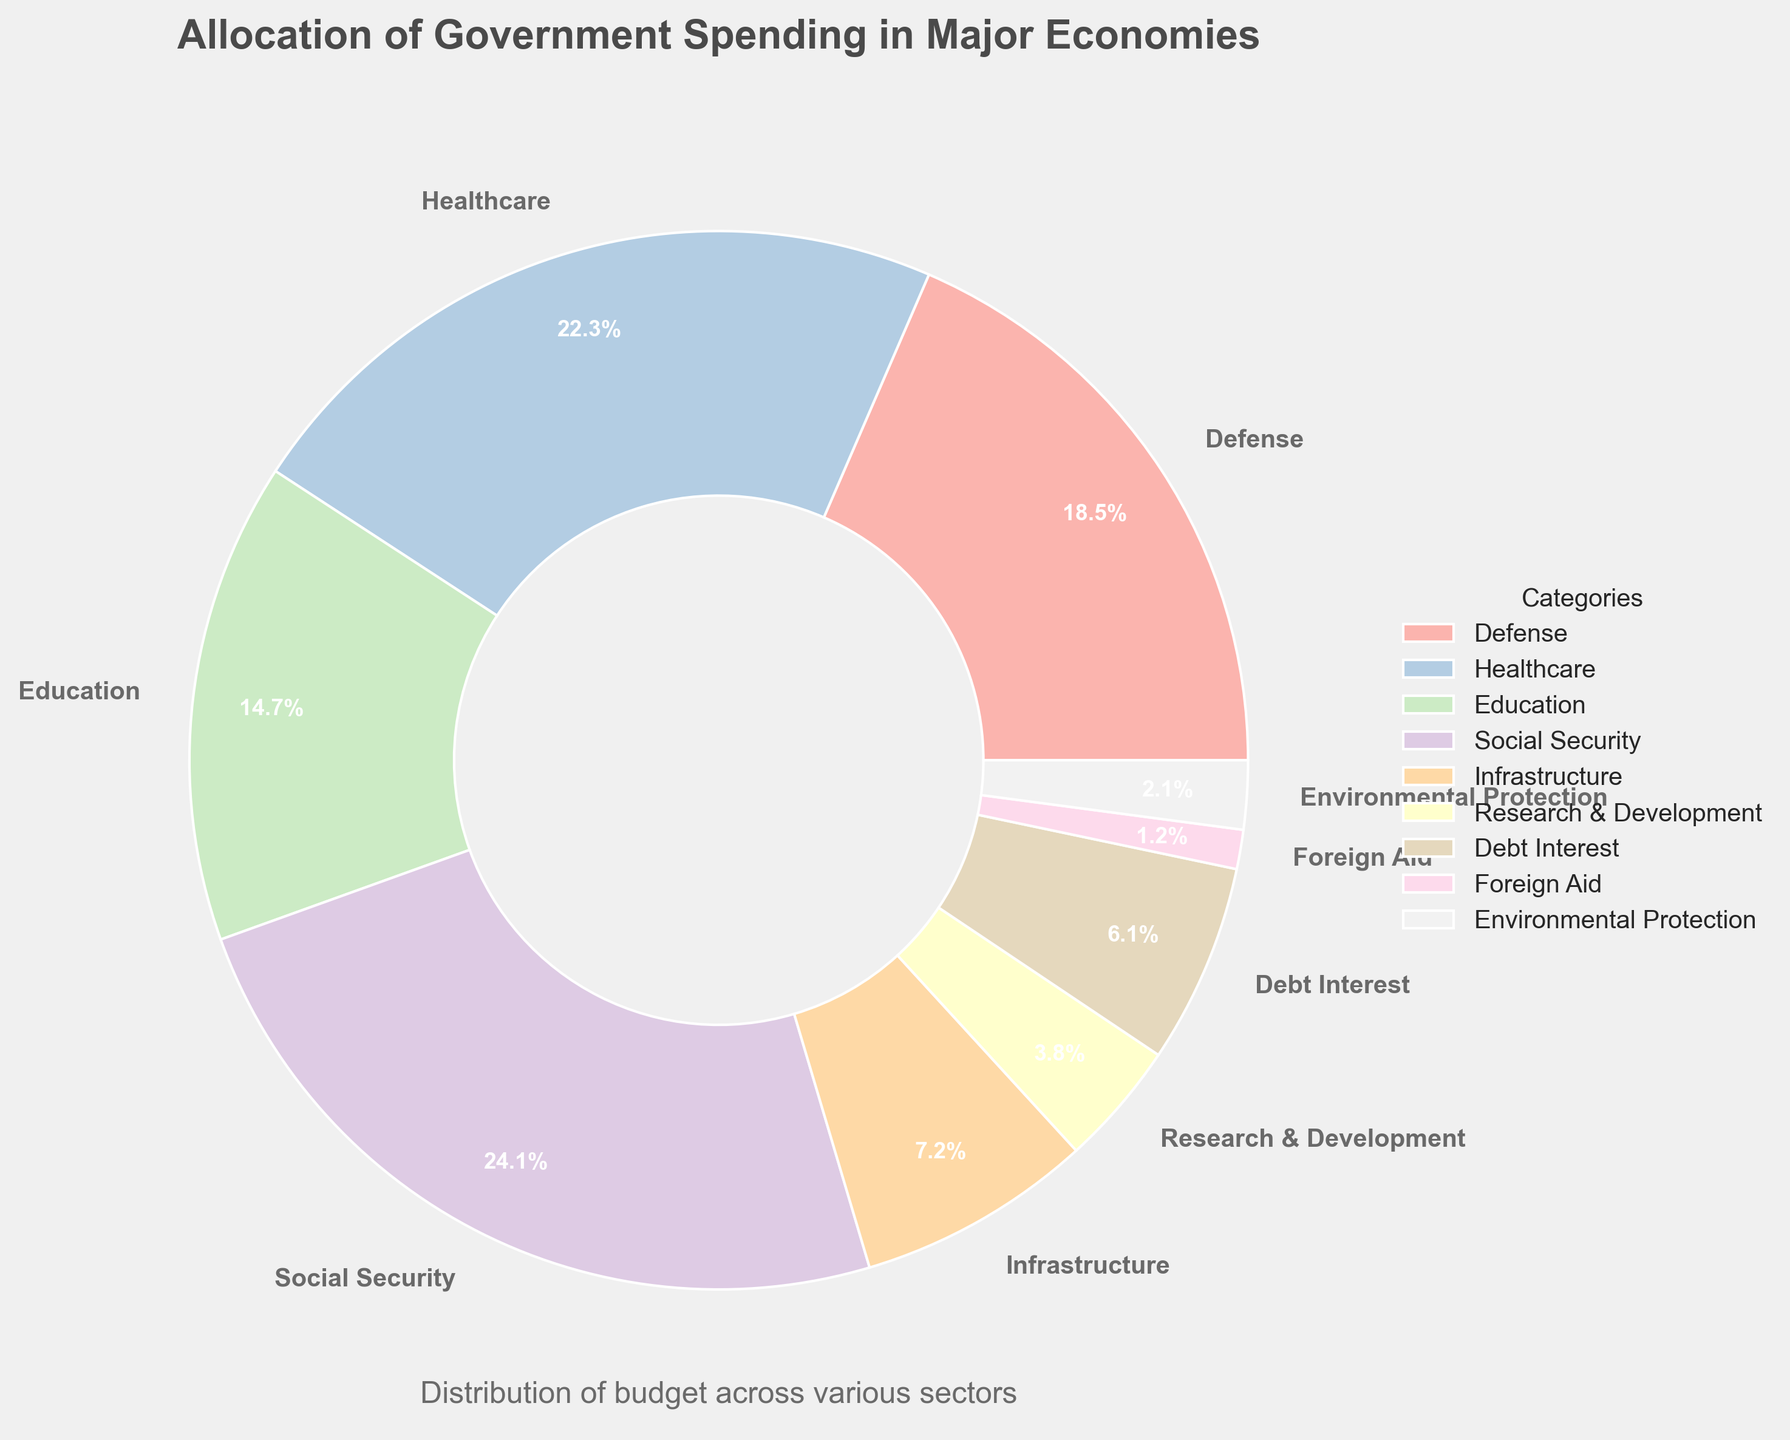What percentage of the budget is allocated to Healthcare and Education combined? To find the combined percentage, sum the percentages for Healthcare and Education. Healthcare has 22.3% and Education has 14.7%. The combined allocation is 22.3% + 14.7% = 37.0%.
Answer: 37.0% Which sector receives more funding, Defense or Debt Interest, and by how much? Compare the percentages allocated to Defense (18.5%) and Debt Interest (6.1%). Calculate the difference: 18.5% - 6.1% = 12.4%. Defense receives 12.4% more funding than Debt Interest.
Answer: Defense by 12.4% What is the total percentage allocated for Social Security, Healthcare, and Education? Sum the percentages for Social Security (24.1%), Healthcare (22.3%), and Education (14.7%). The total percentage is 24.1% + 22.3% + 14.7% = 61.1%.
Answer: 61.1% How does the funding for Infrastructure compare with Research & Development? Infrastructure receives 7.2% and Research & Development receives 3.8%. Since 7.2% > 3.8%, Infrastructure receives more funding. The difference is 7.2% - 3.8% = 3.4%.
Answer: Infrastructure by 3.4% Which category has the smallest allocation and what is it? By looking at the percentages, Foreign Aid has the smallest allocation at 1.2%.
Answer: Foreign Aid at 1.2% Does Debt Interest receive more or less funding than Environmental Protection? Debt Interest has 6.1% and Environmental Protection has 2.1%. Since 6.1% > 2.1%, Debt Interest receives more funding.
Answer: Debt Interest more Which categories are allocated more than 20% of the budget? The categories with more than 20% are Social Security (24.1%) and Healthcare (22.3%).
Answer: Social Security, Healthcare What is the difference between the highest funded and lowest funded categories? The highest funded category is Social Security with 24.1%, and the lowest funded is Foreign Aid with 1.2%. The difference is 24.1% - 1.2% = 22.9%.
Answer: 22.9% In terms of funding, how does Education compare to the combined total of Research & Development and Environmental Protection? Education has 14.7%. The combined total for Research & Development (3.8%) and Environmental Protection (2.1%) is 3.8% + 2.1% = 5.9%. Since 14.7% > 5.9%, Education receives more funding.
Answer: Education more If the combined budget for Research & Development and Foreign Aid were doubled, would it exceed Healthcare’s allocation? The combined budget for Research & Development and Foreign Aid is 3.8% + 1.2% = 5.0%. If doubled: 5.0% * 2 = 10.0%. Since 10.0% < 22.3%, it would still not exceed Healthcare’s allocation.
Answer: No 